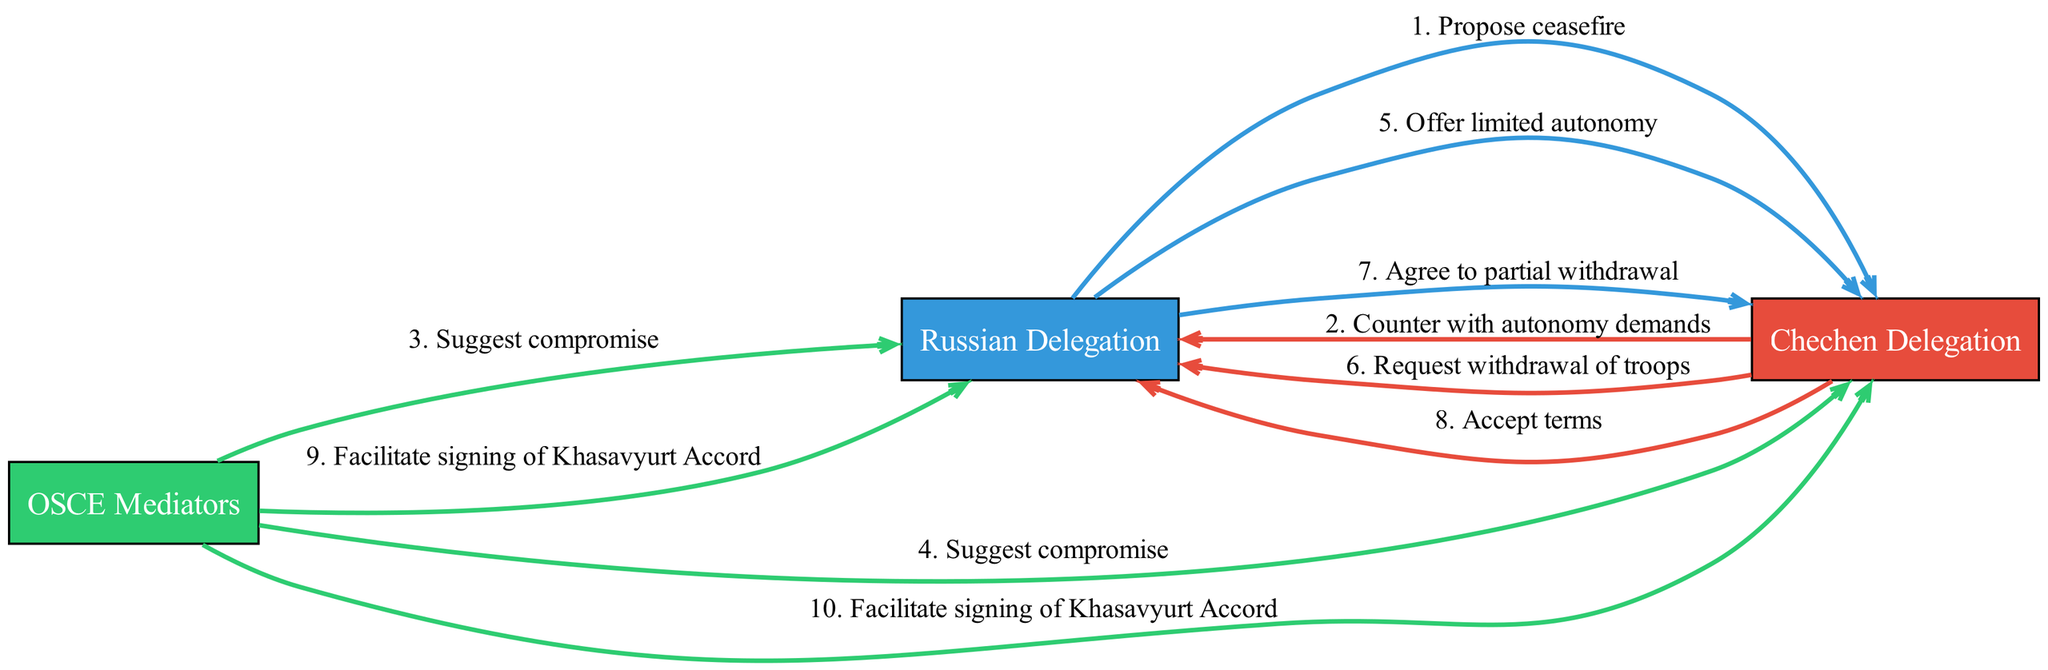What is the first message in the sequence? The first message from the Russian Delegation to the Chechen Delegation is "Propose ceasefire". It is represented as the first edge connecting these two entities.
Answer: Propose ceasefire How many messages are exchanged between the Chechen Delegation and the Russian Delegation? There are a total of 5 messages directly exchanged between these two delegations: "Counter with autonomy demands", "Offer limited autonomy", "Request withdrawal of troops", "Agree to partial withdrawal", and "Accept terms". By counting these edges, we arrive at the answer.
Answer: 5 Which actor suggests a compromise? The OSCE Mediators suggest a compromise to both the Russian and Chechen Delegations as indicated by the edges connecting this actor to both delegations with the message "Suggest compromise".
Answer: OSCE Mediators What was the last action in the negotiation sequence? The last action in the negotiation sequence involves the OSCE Mediators facilitating the signing of the Khasavyurt Accord for both delegations, indicated by the last edges connected to the respective delegations.
Answer: Facilitate signing of Khasavyurt Accord Which message follows the "Counter with autonomy demands" message? Following the "Counter with autonomy demands" from the Chechen Delegation, the next message is from the OSCE Mediators suggesting a compromise. The flow continues from that point, identified by the sequence of messages.
Answer: Suggest compromise How many unique actors are involved in the negotiations? There are three unique actors involved in this negotiation process: the Russian Delegation, the Chechen Delegation, and the OSCE Mediators. Counting the distinct nodes gives this result.
Answer: 3 What is the second-to-last message in the sequence? The second-to-last message is the one where the Chechen Delegation accepts the terms, as it is the second-to-last edge leading to the final action of signing the Khasavyurt Accord.
Answer: Accept terms What type of negotiation is being depicted in this sequence? The sequence primarily depicts diplomatic negotiations between the Russian and Chechen representatives, characterized by formal communications seeking a resolution to conflict.
Answer: Diplomatic negotiations 